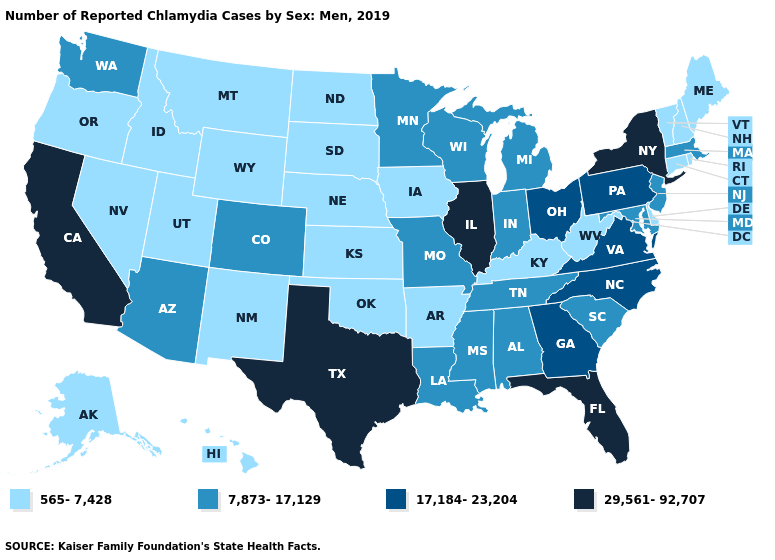What is the lowest value in the USA?
Answer briefly. 565-7,428. Name the states that have a value in the range 29,561-92,707?
Concise answer only. California, Florida, Illinois, New York, Texas. What is the value of Arizona?
Keep it brief. 7,873-17,129. Does Texas have the lowest value in the USA?
Concise answer only. No. What is the highest value in the South ?
Write a very short answer. 29,561-92,707. Among the states that border Wyoming , does Colorado have the highest value?
Be succinct. Yes. Among the states that border North Dakota , does Montana have the lowest value?
Concise answer only. Yes. Does Illinois have the highest value in the MidWest?
Concise answer only. Yes. How many symbols are there in the legend?
Write a very short answer. 4. Does Michigan have the lowest value in the MidWest?
Concise answer only. No. Does Illinois have the highest value in the MidWest?
Write a very short answer. Yes. Does Alaska have the highest value in the West?
Answer briefly. No. Name the states that have a value in the range 17,184-23,204?
Short answer required. Georgia, North Carolina, Ohio, Pennsylvania, Virginia. Does New York have the highest value in the USA?
Keep it brief. Yes. What is the highest value in the MidWest ?
Keep it brief. 29,561-92,707. 